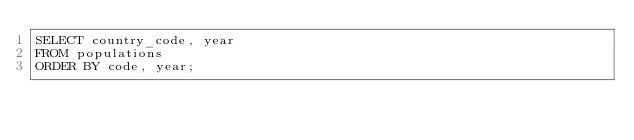Convert code to text. <code><loc_0><loc_0><loc_500><loc_500><_SQL_>SELECT country_code, year
FROM populations
ORDER BY code, year;</code> 